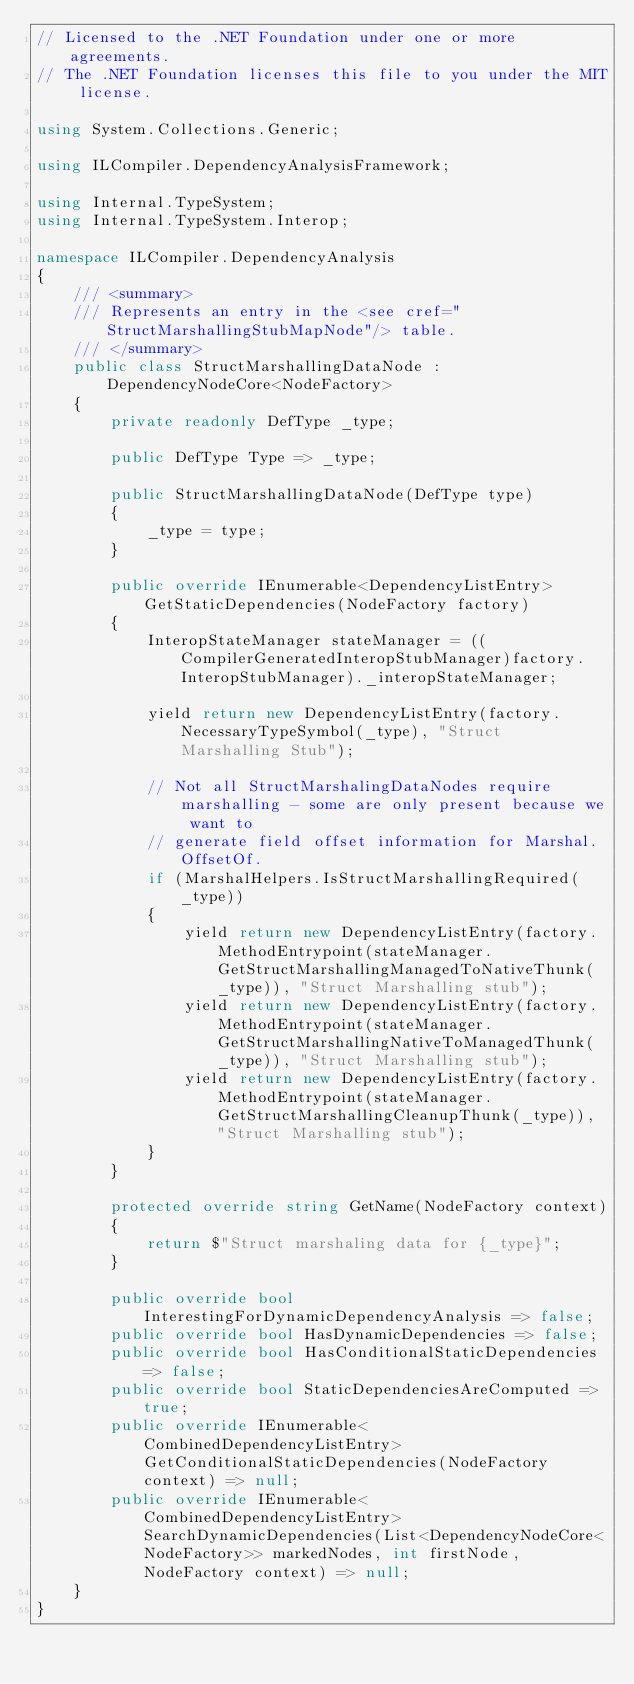<code> <loc_0><loc_0><loc_500><loc_500><_C#_>// Licensed to the .NET Foundation under one or more agreements.
// The .NET Foundation licenses this file to you under the MIT license.

using System.Collections.Generic;

using ILCompiler.DependencyAnalysisFramework;

using Internal.TypeSystem;
using Internal.TypeSystem.Interop;

namespace ILCompiler.DependencyAnalysis
{
    /// <summary>
    /// Represents an entry in the <see cref="StructMarshallingStubMapNode"/> table.
    /// </summary>
    public class StructMarshallingDataNode : DependencyNodeCore<NodeFactory>
    {
        private readonly DefType _type;

        public DefType Type => _type;

        public StructMarshallingDataNode(DefType type)
        {
            _type = type;
        }

        public override IEnumerable<DependencyListEntry> GetStaticDependencies(NodeFactory factory)
        {
            InteropStateManager stateManager = ((CompilerGeneratedInteropStubManager)factory.InteropStubManager)._interopStateManager;

            yield return new DependencyListEntry(factory.NecessaryTypeSymbol(_type), "Struct Marshalling Stub");

            // Not all StructMarshalingDataNodes require marshalling - some are only present because we want to
            // generate field offset information for Marshal.OffsetOf.
            if (MarshalHelpers.IsStructMarshallingRequired(_type))
            {
                yield return new DependencyListEntry(factory.MethodEntrypoint(stateManager.GetStructMarshallingManagedToNativeThunk(_type)), "Struct Marshalling stub");
                yield return new DependencyListEntry(factory.MethodEntrypoint(stateManager.GetStructMarshallingNativeToManagedThunk(_type)), "Struct Marshalling stub");
                yield return new DependencyListEntry(factory.MethodEntrypoint(stateManager.GetStructMarshallingCleanupThunk(_type)), "Struct Marshalling stub");
            }
        }

        protected override string GetName(NodeFactory context)
        {
            return $"Struct marshaling data for {_type}";
        }

        public override bool InterestingForDynamicDependencyAnalysis => false;
        public override bool HasDynamicDependencies => false;
        public override bool HasConditionalStaticDependencies => false;
        public override bool StaticDependenciesAreComputed => true;
        public override IEnumerable<CombinedDependencyListEntry> GetConditionalStaticDependencies(NodeFactory context) => null;
        public override IEnumerable<CombinedDependencyListEntry> SearchDynamicDependencies(List<DependencyNodeCore<NodeFactory>> markedNodes, int firstNode, NodeFactory context) => null;
    }
}
</code> 